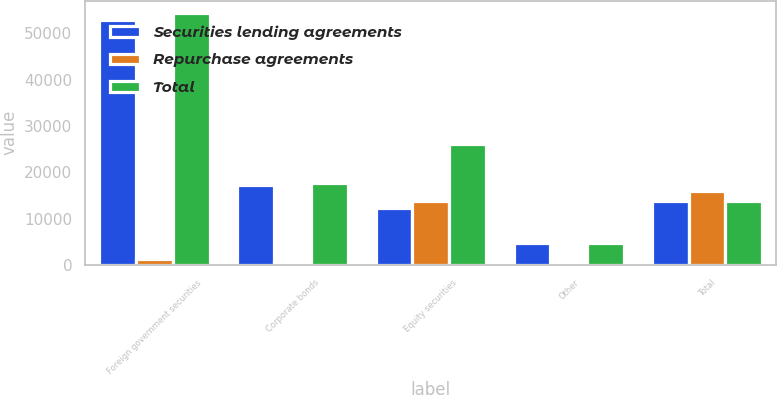<chart> <loc_0><loc_0><loc_500><loc_500><stacked_bar_chart><ecel><fcel>Foreign government securities<fcel>Corporate bonds<fcel>Equity securities<fcel>Other<fcel>Total<nl><fcel>Securities lending agreements<fcel>52988<fcel>17164<fcel>12206<fcel>4692<fcel>13913<nl><fcel>Repurchase agreements<fcel>1390<fcel>630<fcel>13913<fcel>25<fcel>15958<nl><fcel>Total<fcel>54378<fcel>17794<fcel>26119<fcel>4717<fcel>13913<nl></chart> 